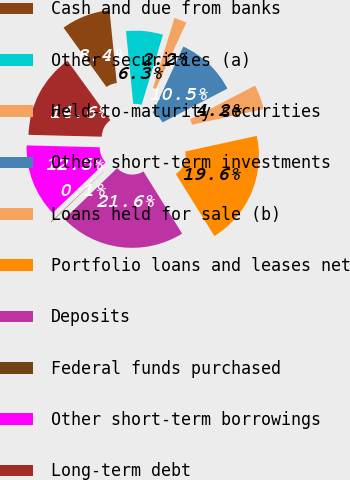<chart> <loc_0><loc_0><loc_500><loc_500><pie_chart><fcel>Cash and due from banks<fcel>Other securities (a)<fcel>Held-to-maturity securities<fcel>Other short-term investments<fcel>Loans held for sale (b)<fcel>Portfolio loans and leases net<fcel>Deposits<fcel>Federal funds purchased<fcel>Other short-term borrowings<fcel>Long-term debt<nl><fcel>8.39%<fcel>6.31%<fcel>2.15%<fcel>10.47%<fcel>4.23%<fcel>19.56%<fcel>21.64%<fcel>0.08%<fcel>12.54%<fcel>14.62%<nl></chart> 